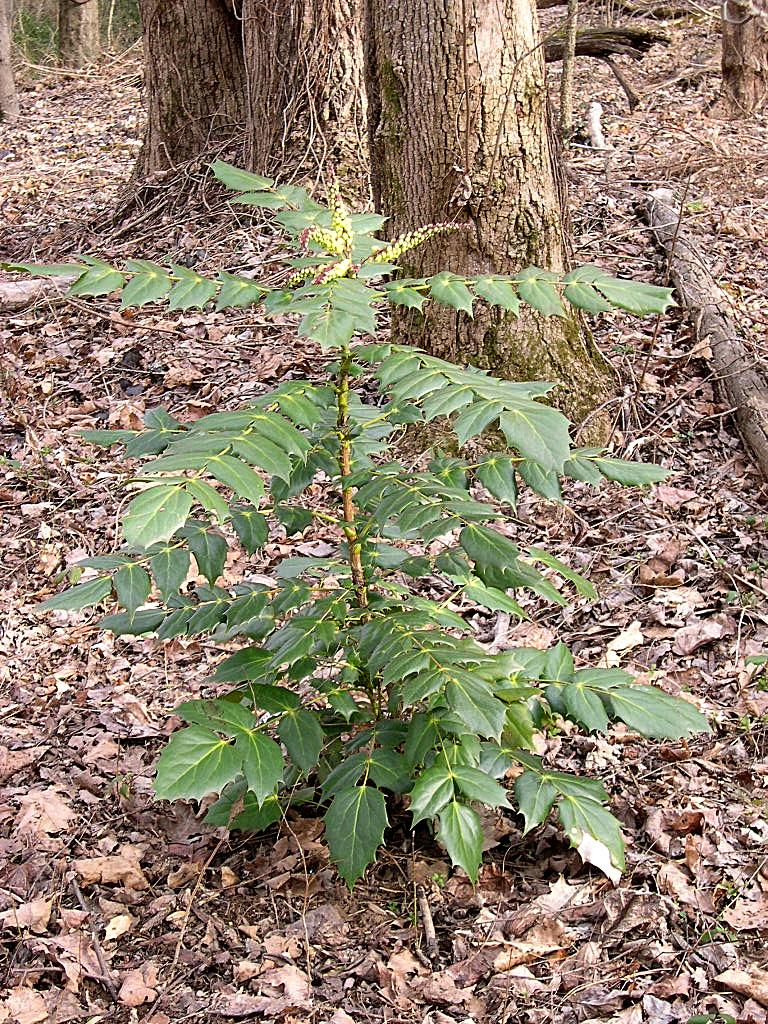What is located in the foreground of the image? There is a plant and dry leaves in the foreground of the image. What can be seen in the background of the image? There are trunks in the background of the image. What type of music can be heard playing in the background of the image? There is no music present in the image, as it is a still photograph. What color is the copper object in the image? There is no copper object present in the image. 